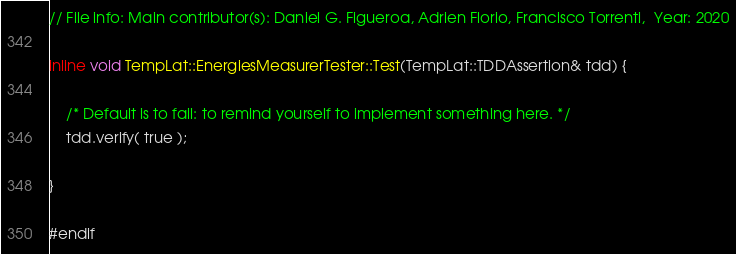Convert code to text. <code><loc_0><loc_0><loc_500><loc_500><_C_>// File info: Main contributor(s): Daniel G. Figueroa, Adrien Florio, Francisco Torrenti,  Year: 2020

inline void TempLat::EnergiesMeasurerTester::Test(TempLat::TDDAssertion& tdd) {

    /* Default is to fail: to remind yourself to implement something here. */
    tdd.verify( true );

}

#endif
</code> 